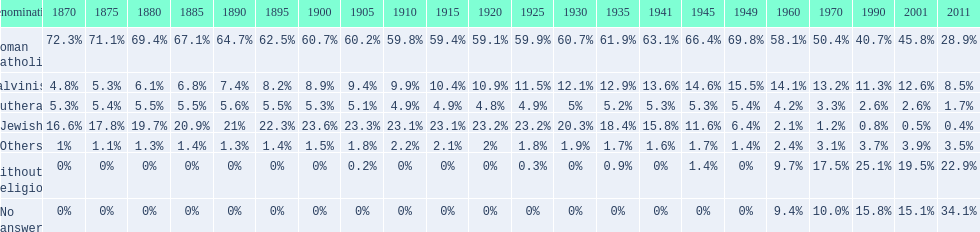Which denomination has the highest margin? Roman Catholic. 